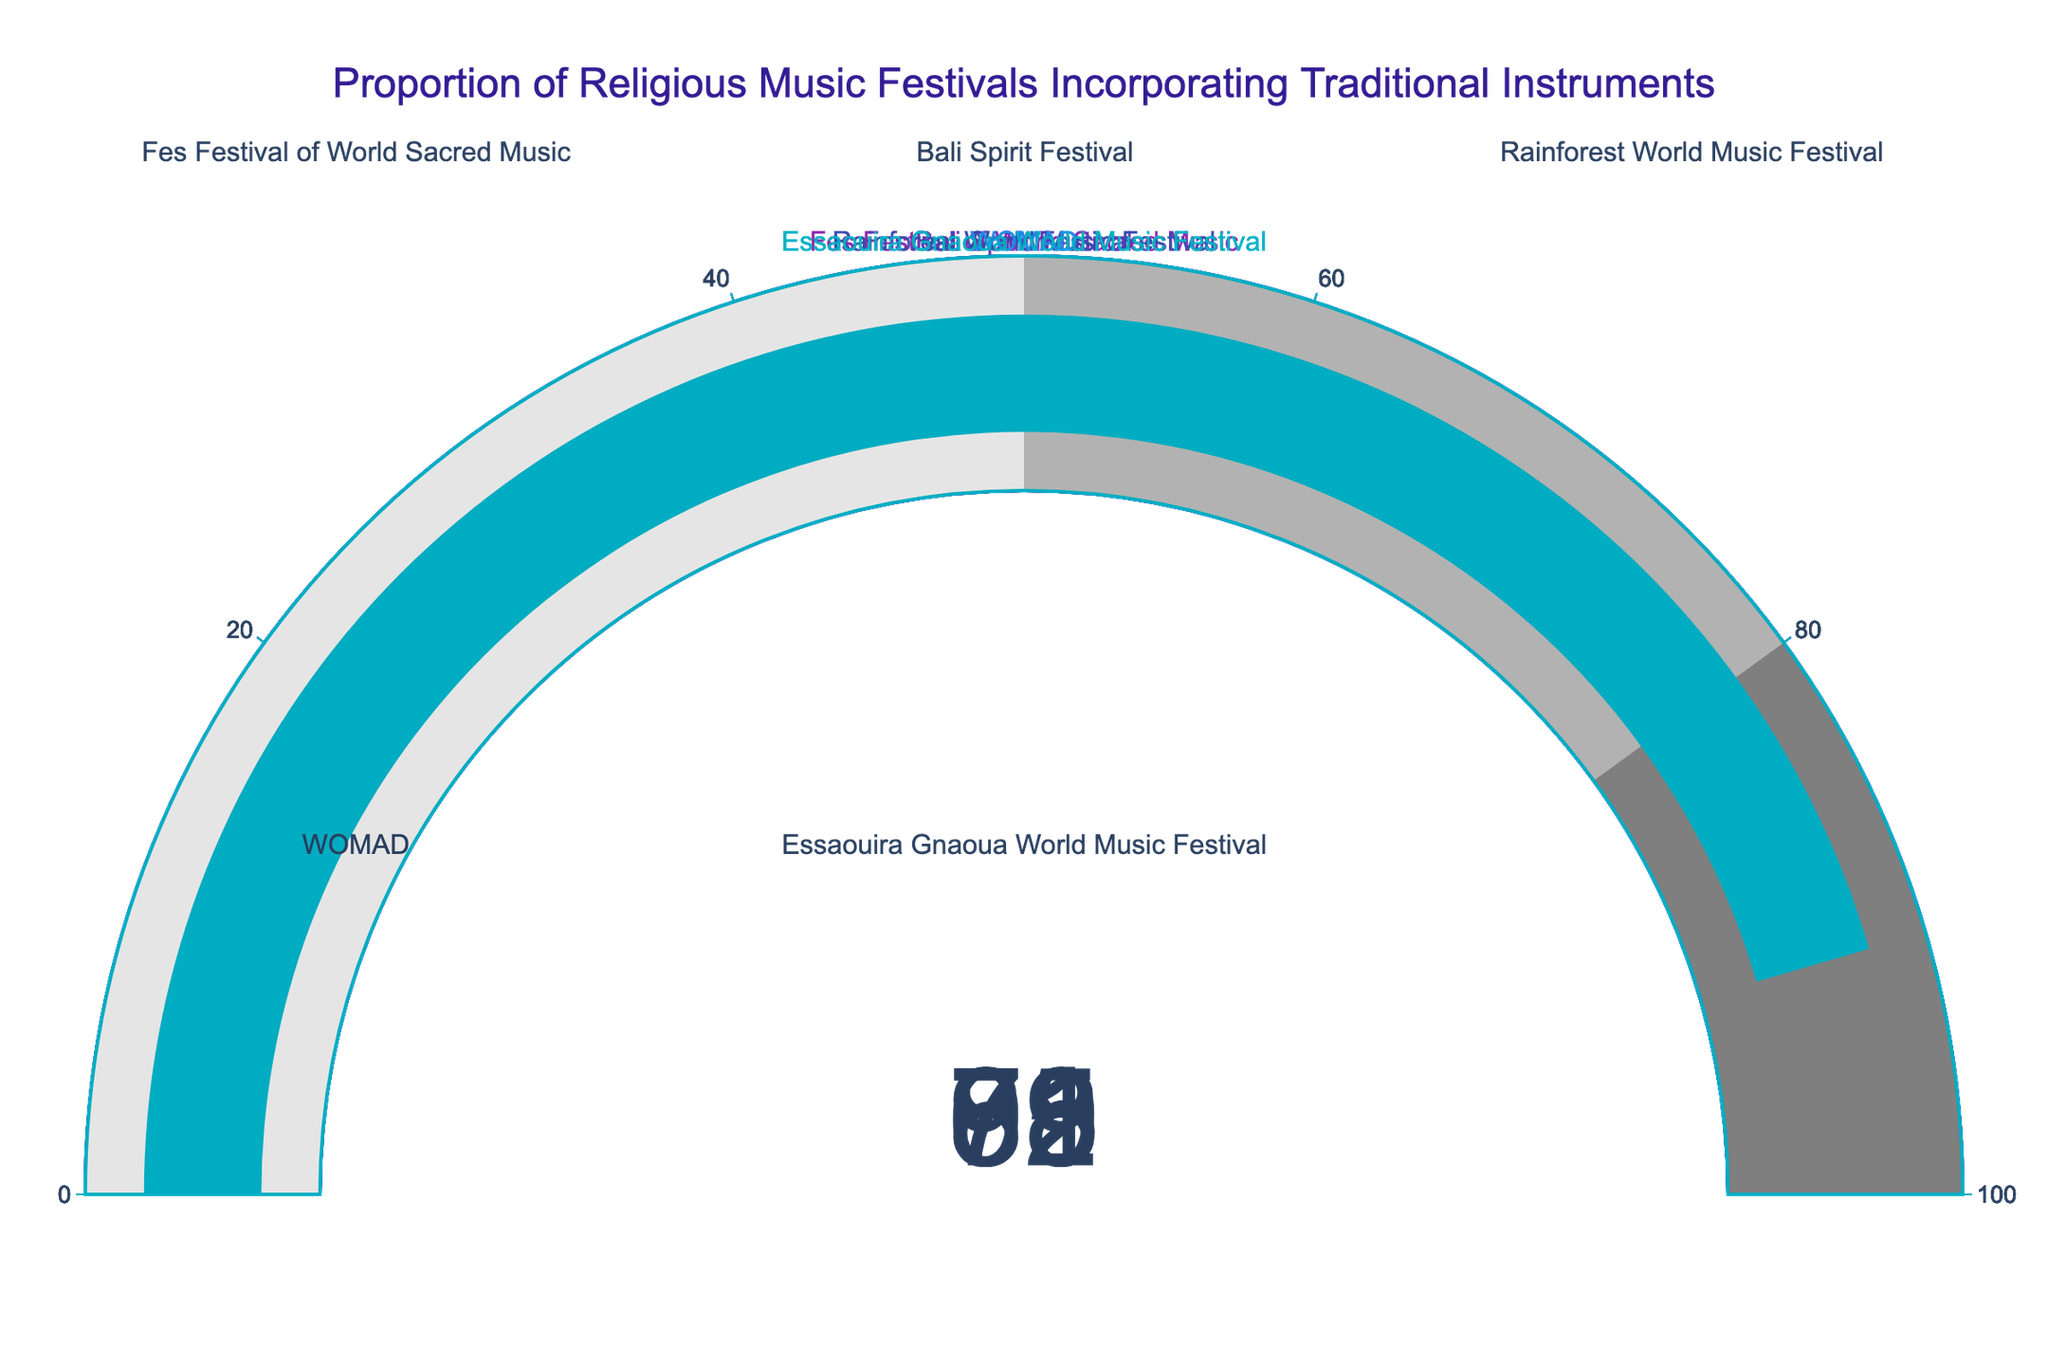What is the highest proportion of traditional instruments used in the festivals? Look for the gauge with the highest value. In this case, it is the Essaouira Gnaoua World Music Festival with 91% (0.91 * 100).
Answer: 91% What is the range of proportions across the festivals? Identify the lowest and highest values displayed on the gauges. The lowest is 68% (Rainforest World Music Festival), and the highest is 91% (Essaouira Gnaoua World Music Festival). The range is 91% - 68% = 23%.
Answer: 23% Which festival has the lowest proportion of traditional instruments? Compare the values on each gauge and identify the lowest one, which is the Rainforest World Music Festival at 68%.
Answer: Rainforest World Music Festival What is the average proportion of traditional instruments across all festivals? Add all the proportions together and divide by the number of festivals: (85 + 72 + 68 + 79 + 91) / 5 = 395 / 5 = 79%.
Answer: 79% How does the WOMAD festival compare to the Bali Spirit Festival in terms of the use of traditional instruments? Compare the values of both festivals. WOMAD has 79%, and Bali Spirit Festival has 72%. WOMAD has a higher proportion of 7%.
Answer: WOMAD is 7% higher What is the median proportion of traditional instruments used among the festivals? Arrange the proportions in ascending order: 68, 72, 79, 85, 91. The median value (middle value) is the third one, which is 79%.
Answer: 79% How many festivals have a proportion of traditional instruments usage greater than 80%? Count the number of festivals with proportions greater than 80%: Fes Festival of World Sacred Music (85%) and Essaouira Gnaoua World Music Festival (91%). There are 2 such festivals.
Answer: 2 Which festival comes second in terms of the highest proportion of traditional instruments? Find the second highest value after the highest (91%). The second highest is 85%, which belongs to the Fes Festival of World Sacred Music.
Answer: Fes Festival of World Sacred Music If the total number of festivals were 10 with the same proportions, how many would have a proportion lower than 75%? Identify festivals with proportions lower than 75%: Bali Spirit Festival (72%) and Rainforest World Music Festival (68%). There are 2 out of 5 festivals with lower than 75%. For 10 festivals, proportionately it would be 2/5 * 10 = 4.
Answer: 4 